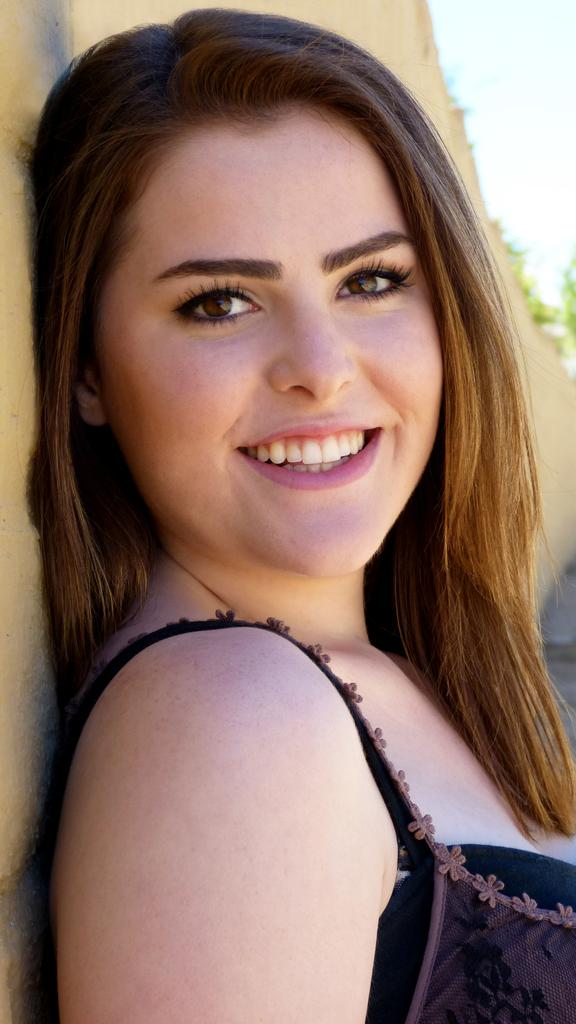Who is present in the image? There is a woman in the image. What is the woman's facial expression? The woman is smiling. Can you describe the background of the image? The background of the image is blurred. How many spiders are crawling on the woman's shoulder in the image? There are no spiders present in the image. What type of gate can be seen in the background of the image? There is no gate visible in the image, as the background is blurred. 